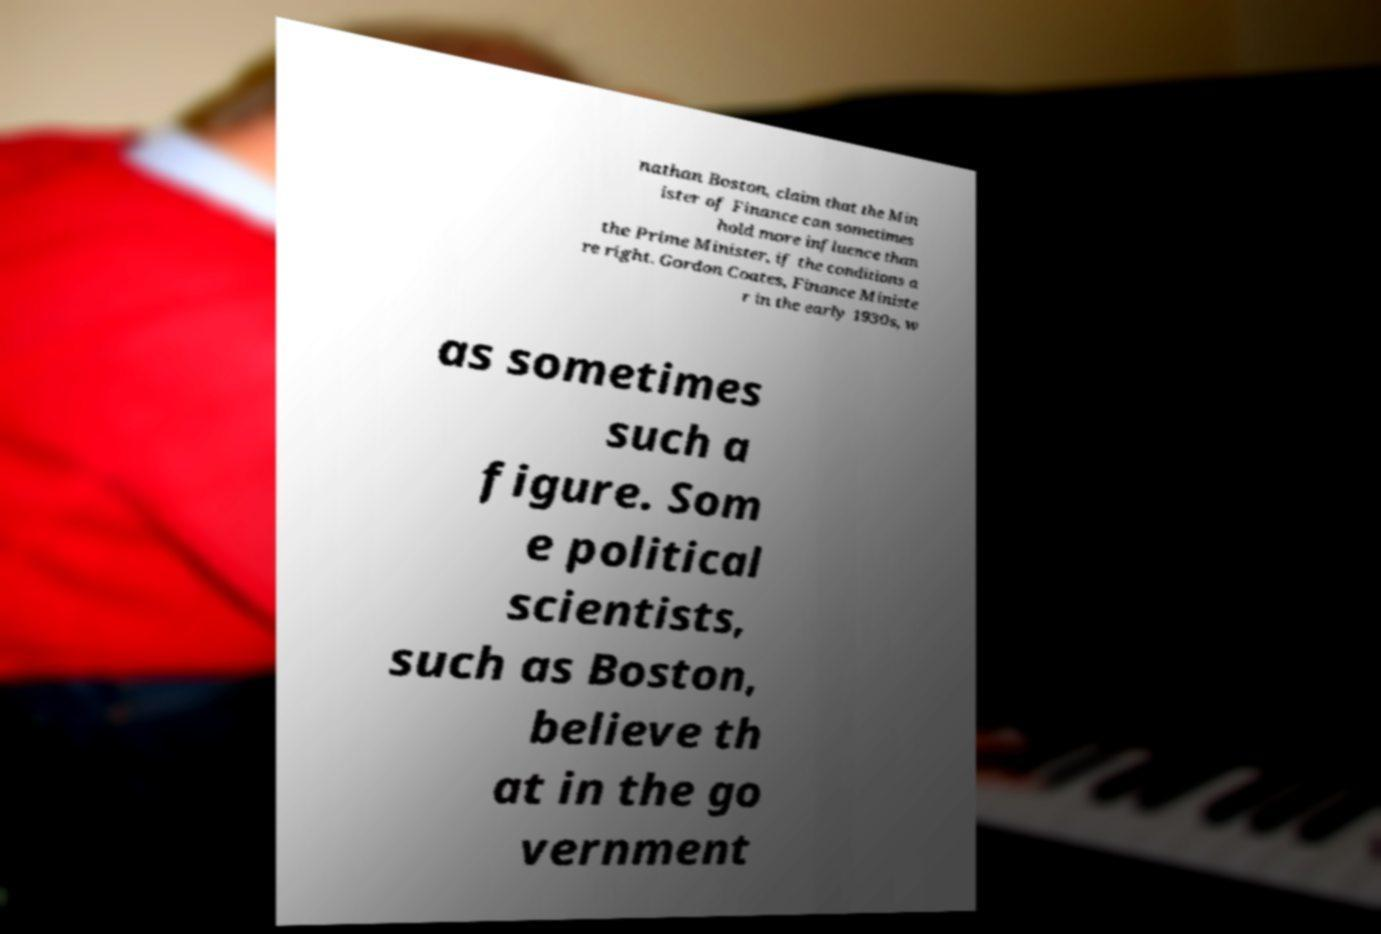Please identify and transcribe the text found in this image. nathan Boston, claim that the Min ister of Finance can sometimes hold more influence than the Prime Minister, if the conditions a re right. Gordon Coates, Finance Ministe r in the early 1930s, w as sometimes such a figure. Som e political scientists, such as Boston, believe th at in the go vernment 